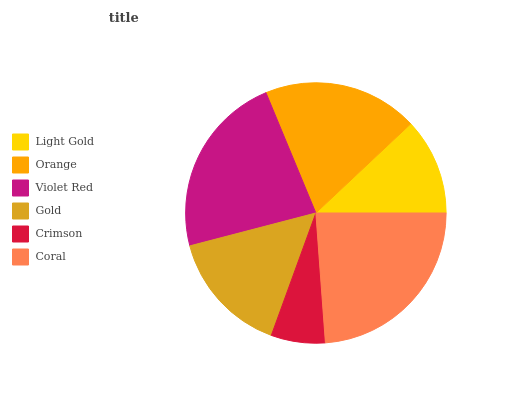Is Crimson the minimum?
Answer yes or no. Yes. Is Coral the maximum?
Answer yes or no. Yes. Is Orange the minimum?
Answer yes or no. No. Is Orange the maximum?
Answer yes or no. No. Is Orange greater than Light Gold?
Answer yes or no. Yes. Is Light Gold less than Orange?
Answer yes or no. Yes. Is Light Gold greater than Orange?
Answer yes or no. No. Is Orange less than Light Gold?
Answer yes or no. No. Is Orange the high median?
Answer yes or no. Yes. Is Gold the low median?
Answer yes or no. Yes. Is Crimson the high median?
Answer yes or no. No. Is Coral the low median?
Answer yes or no. No. 